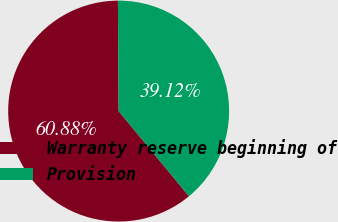<chart> <loc_0><loc_0><loc_500><loc_500><pie_chart><fcel>Warranty reserve beginning of<fcel>Provision<nl><fcel>60.88%<fcel>39.12%<nl></chart> 